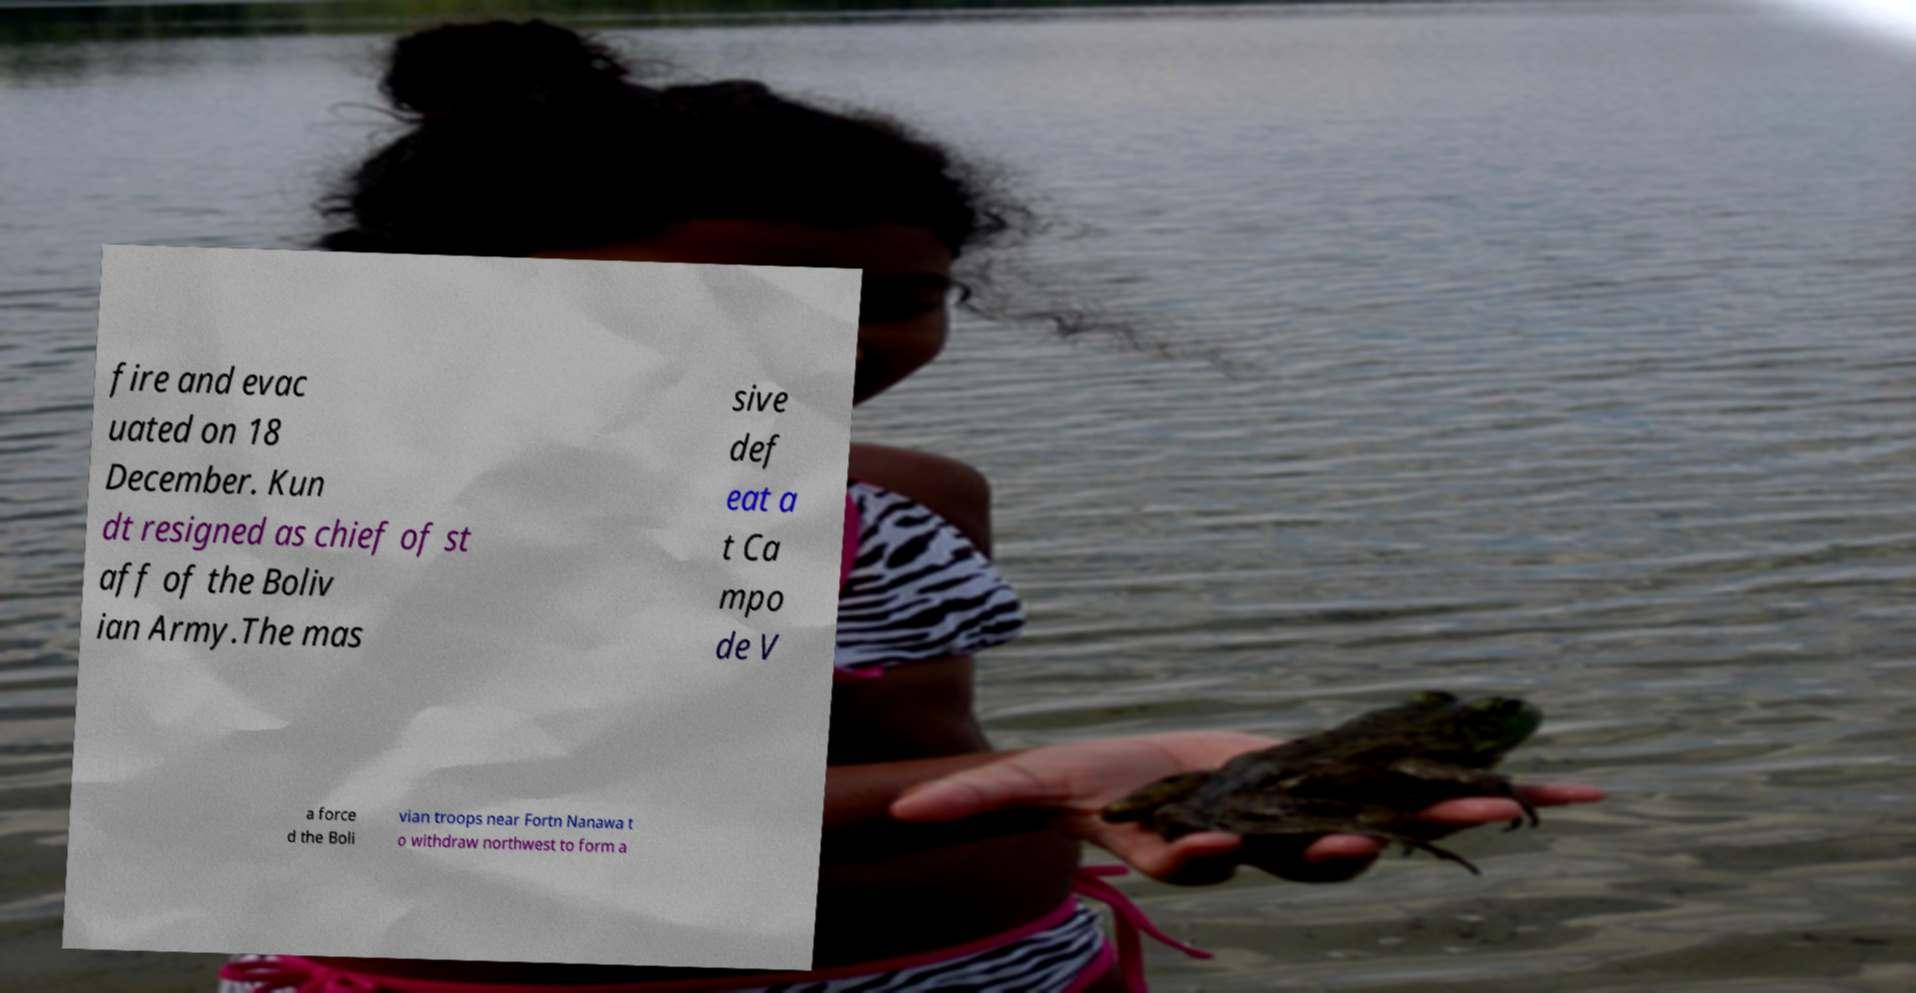Please identify and transcribe the text found in this image. fire and evac uated on 18 December. Kun dt resigned as chief of st aff of the Boliv ian Army.The mas sive def eat a t Ca mpo de V a force d the Boli vian troops near Fortn Nanawa t o withdraw northwest to form a 